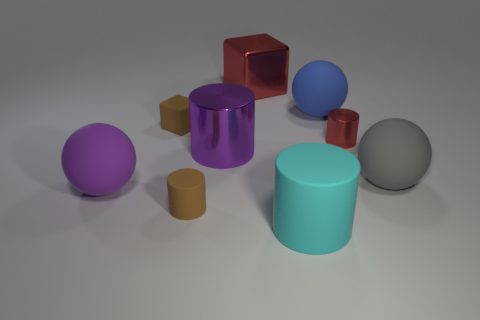There is a large red shiny object; is it the same shape as the brown rubber object in front of the purple metallic object?
Provide a short and direct response. No. There is a large gray matte thing that is in front of the small rubber thing that is behind the matte cylinder that is on the left side of the big metal cube; what is its shape?
Ensure brevity in your answer.  Sphere. How many other things are made of the same material as the gray sphere?
Offer a terse response. 5. How many things are either rubber spheres to the left of the large metal cylinder or large red things?
Give a very brief answer. 2. What is the shape of the large matte thing to the left of the red metal object that is to the left of the red cylinder?
Give a very brief answer. Sphere. There is a tiny brown thing in front of the brown rubber cube; is its shape the same as the purple matte thing?
Keep it short and to the point. No. There is a cylinder that is behind the big purple shiny object; what color is it?
Your answer should be compact. Red. What number of cylinders are big gray things or big purple things?
Provide a succinct answer. 1. There is a purple object that is in front of the rubber sphere to the right of the tiny red shiny cylinder; how big is it?
Ensure brevity in your answer.  Large. Is the color of the large metallic cylinder the same as the rubber sphere that is in front of the gray rubber object?
Your answer should be very brief. Yes. 